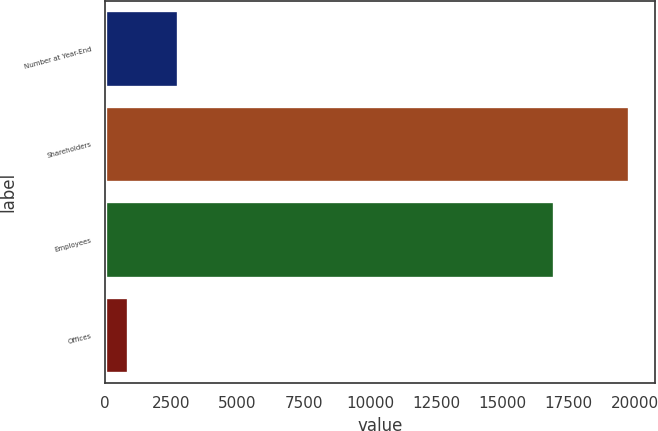Convert chart. <chart><loc_0><loc_0><loc_500><loc_500><bar_chart><fcel>Number at Year-End<fcel>Shareholders<fcel>Employees<fcel>Offices<nl><fcel>2749.7<fcel>19802<fcel>16973<fcel>855<nl></chart> 